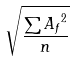Convert formula to latex. <formula><loc_0><loc_0><loc_500><loc_500>\sqrt { \frac { \sum { A _ { f } } ^ { 2 } } { n } }</formula> 